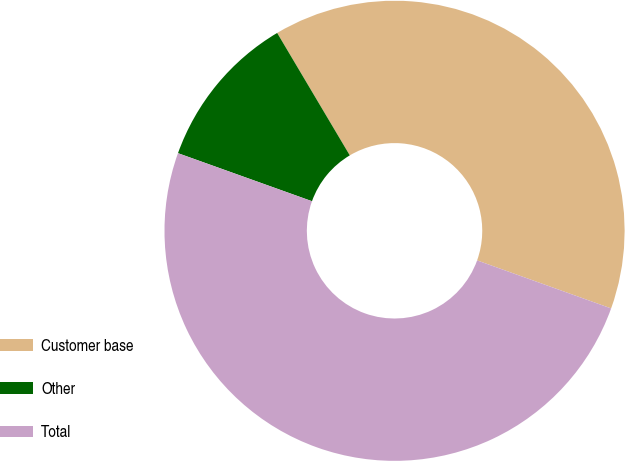<chart> <loc_0><loc_0><loc_500><loc_500><pie_chart><fcel>Customer base<fcel>Other<fcel>Total<nl><fcel>39.0%<fcel>11.0%<fcel>50.0%<nl></chart> 